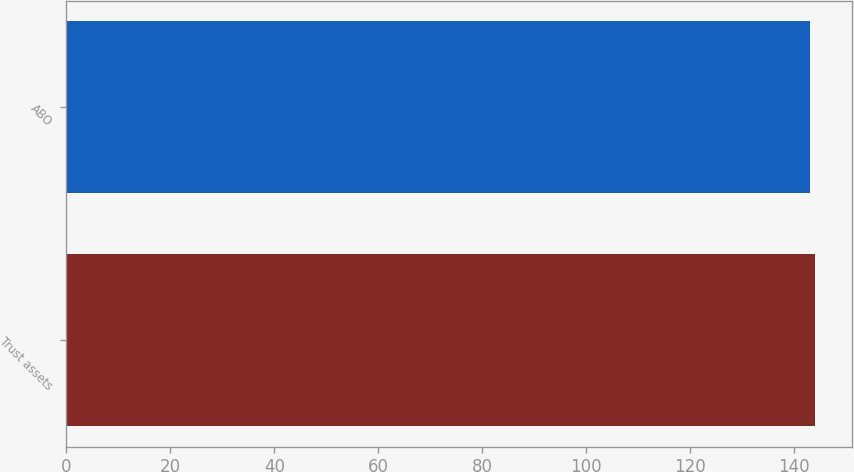Convert chart. <chart><loc_0><loc_0><loc_500><loc_500><bar_chart><fcel>Trust assets<fcel>ABO<nl><fcel>144<fcel>143<nl></chart> 